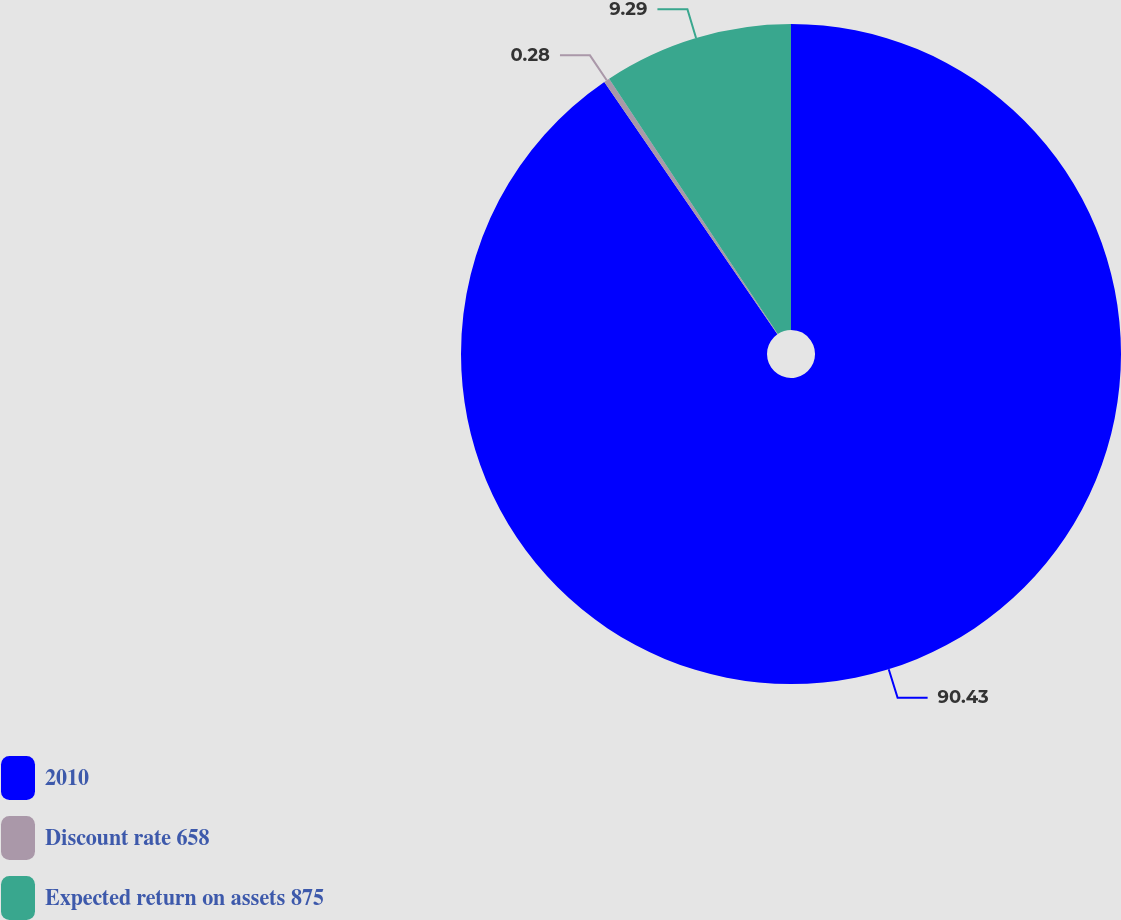<chart> <loc_0><loc_0><loc_500><loc_500><pie_chart><fcel>2010<fcel>Discount rate 658<fcel>Expected return on assets 875<nl><fcel>90.43%<fcel>0.28%<fcel>9.29%<nl></chart> 